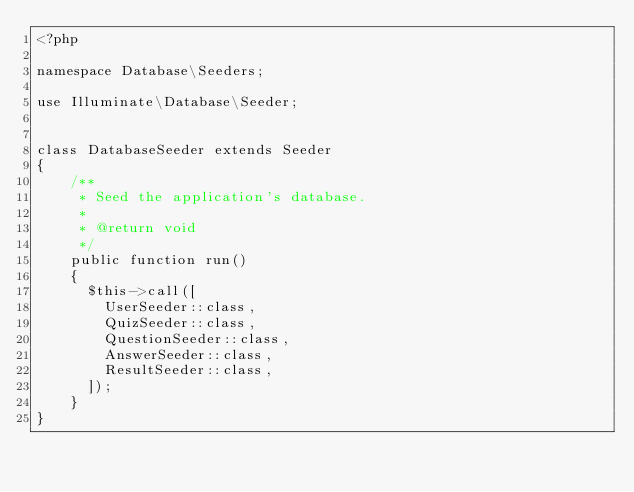Convert code to text. <code><loc_0><loc_0><loc_500><loc_500><_PHP_><?php

namespace Database\Seeders;

use Illuminate\Database\Seeder;


class DatabaseSeeder extends Seeder
{
    /**
     * Seed the application's database.
     *
     * @return void
     */
    public function run()
    {
      $this->call([
        UserSeeder::class,
        QuizSeeder::class,
        QuestionSeeder::class,
        AnswerSeeder::class,
        ResultSeeder::class,
      ]);
    }
}
</code> 